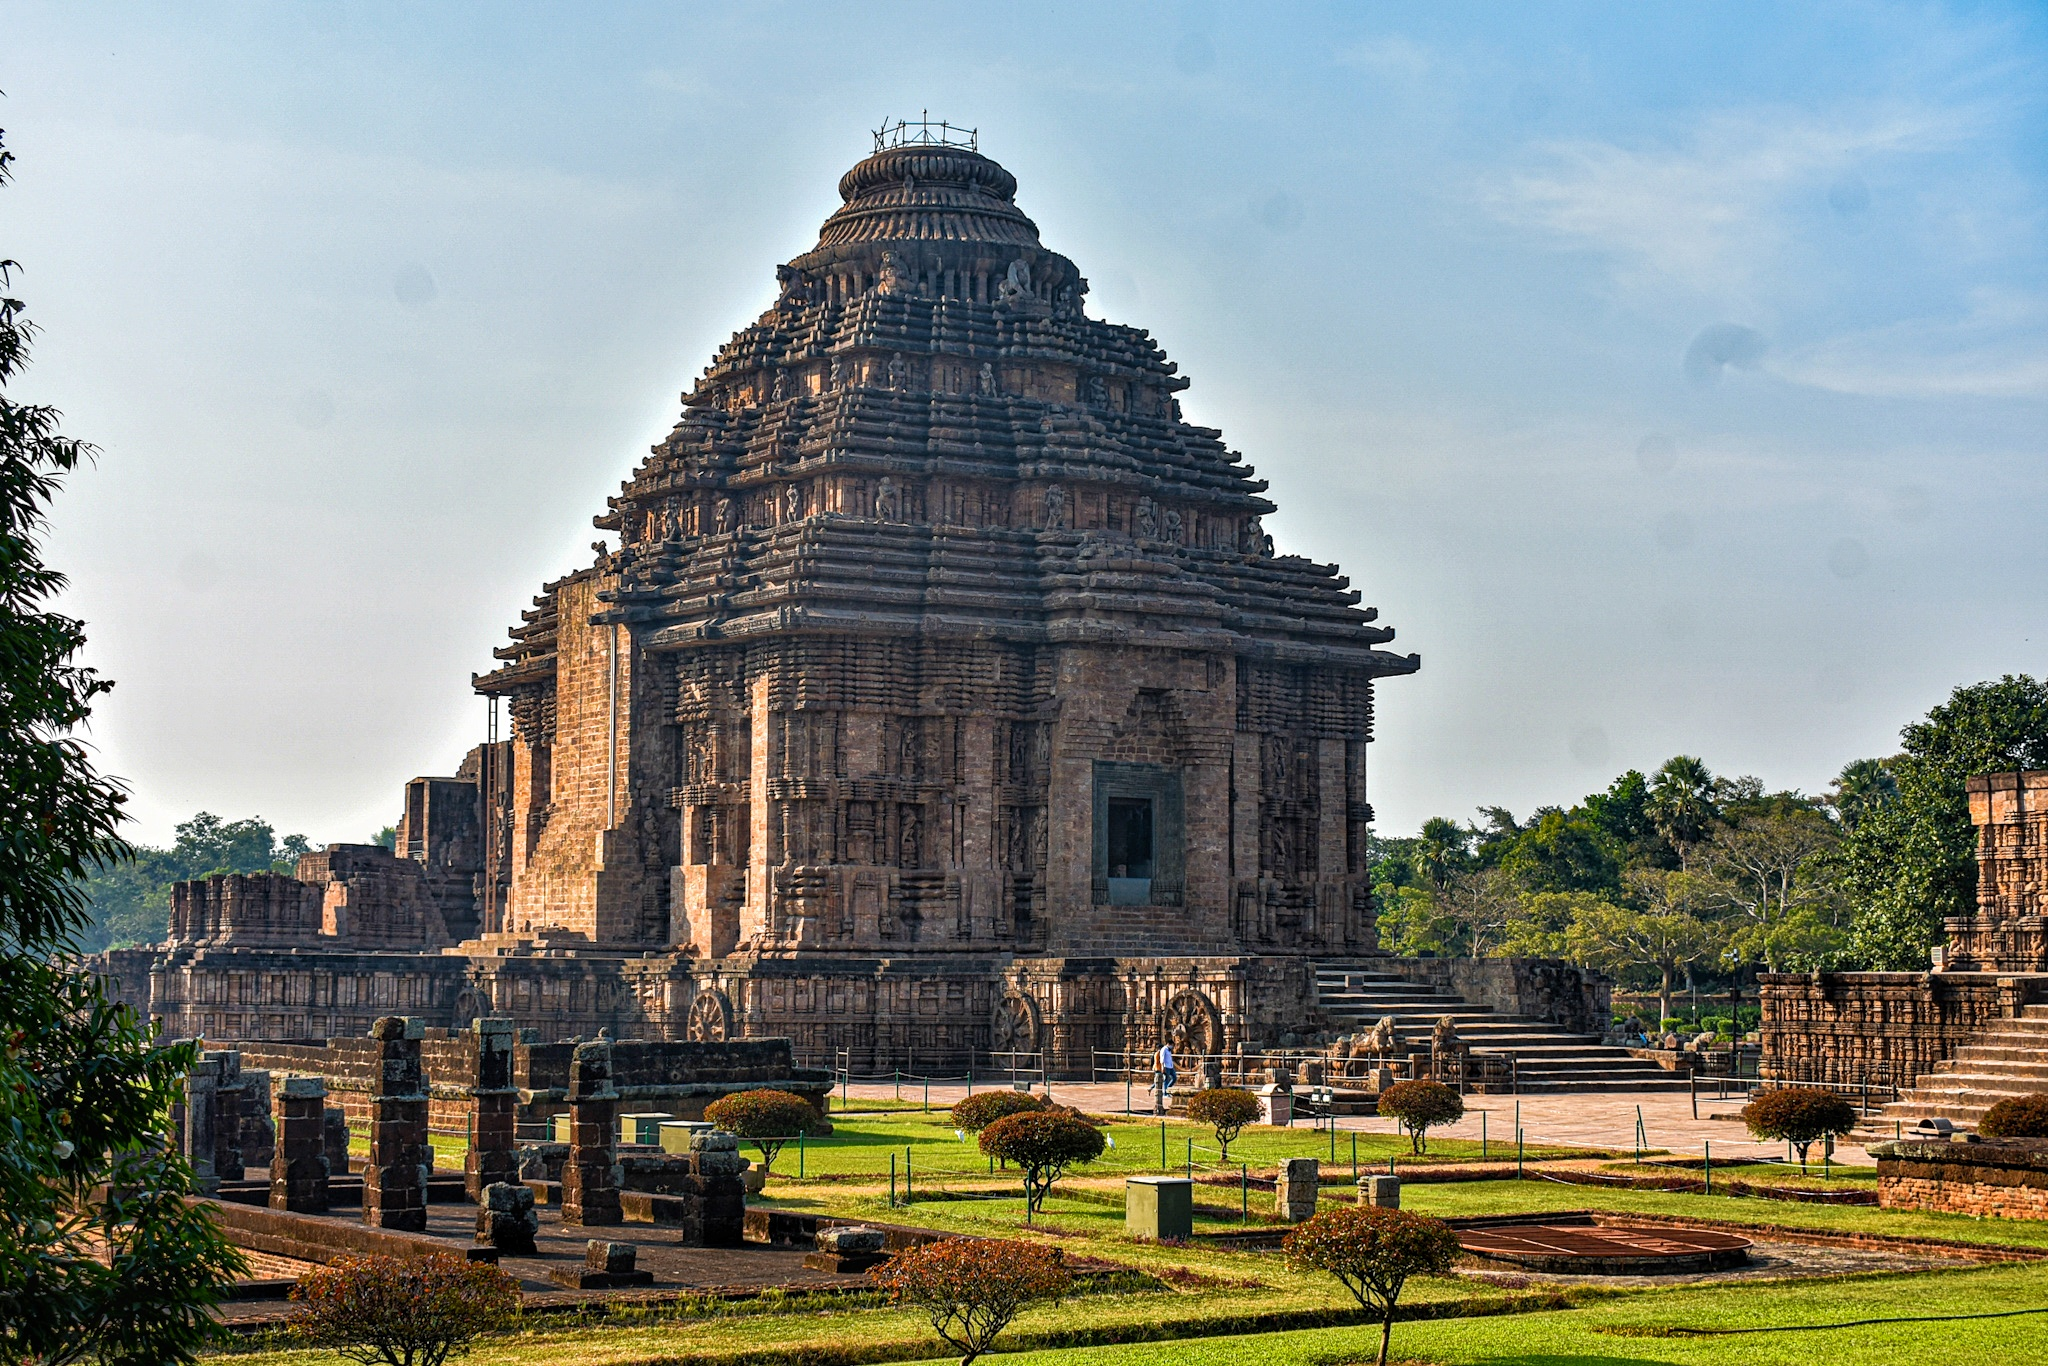Can you tell me more about the significance of the temple's design as a chariot? Certainly! The Konark Sun Temple's design as a gigantic stone chariot symbolizes the passage of the Sun god Surya across the heavens. Each of the 24 intricately carved wheels aligned along the base of the temple represents an hour of the day, highlighting the temporal cycle and the perpetual movement of time. The seven horses that pull the chariot symbolize the seven days of the week, reflecting the cosmological and astrological significance embedded in its architecture. This unique design not only embodies theological symbolism but also reflects the advanced astronomical knowledge of the architects of the era. 